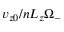<formula> <loc_0><loc_0><loc_500><loc_500>v _ { z 0 } / n L _ { z } \Omega _ { - }</formula> 